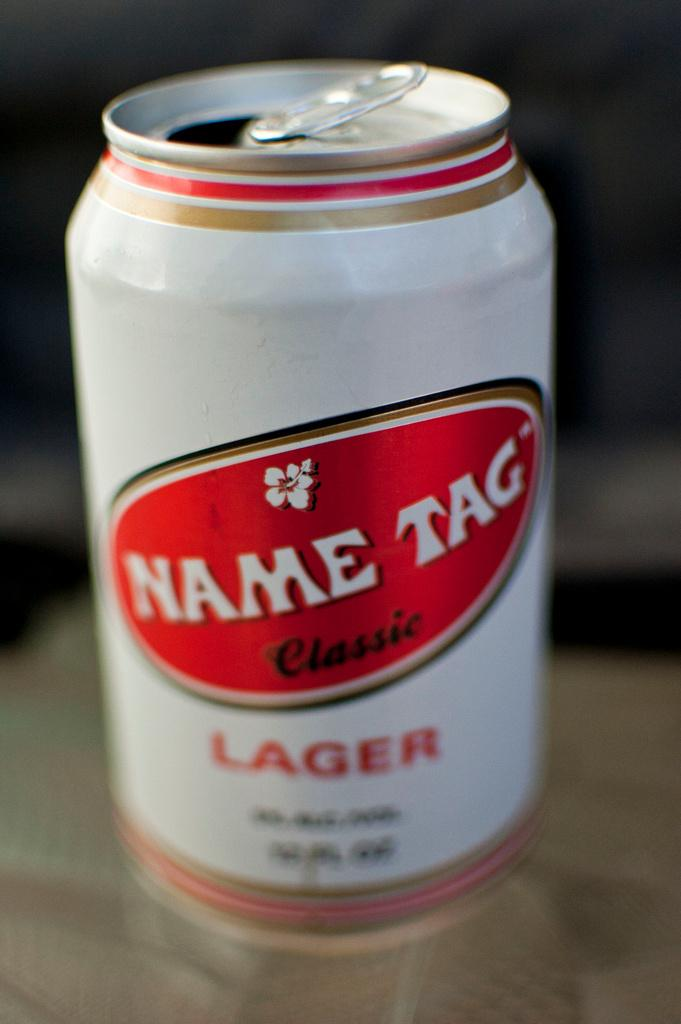<image>
Present a compact description of the photo's key features. A can of beer called Name Tag Classic has been opened. 